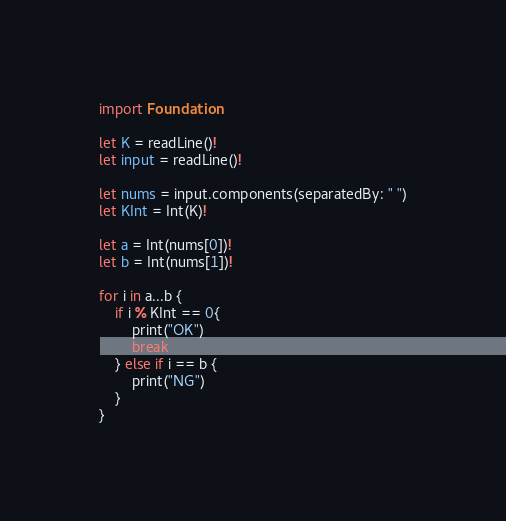<code> <loc_0><loc_0><loc_500><loc_500><_Swift_>import Foundation

let K = readLine()!
let input = readLine()!

let nums = input.components(separatedBy: " ")
let KInt = Int(K)!

let a = Int(nums[0])!
let b = Int(nums[1])!

for i in a...b {
    if i % KInt == 0{
        print("OK")
        break
    } else if i == b {
        print("NG")
    }
}</code> 